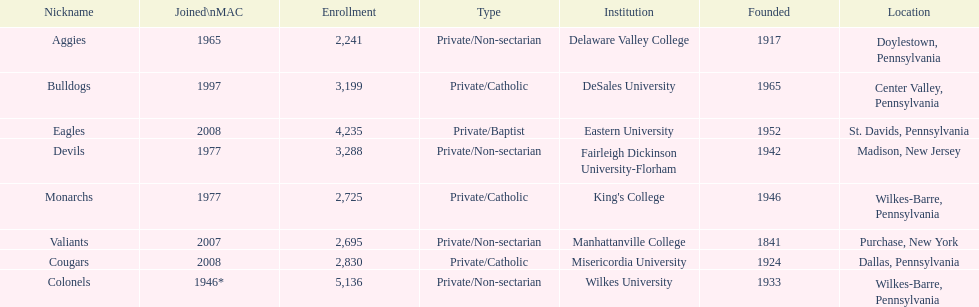How many are enrolled in private/catholic? 8,754. 